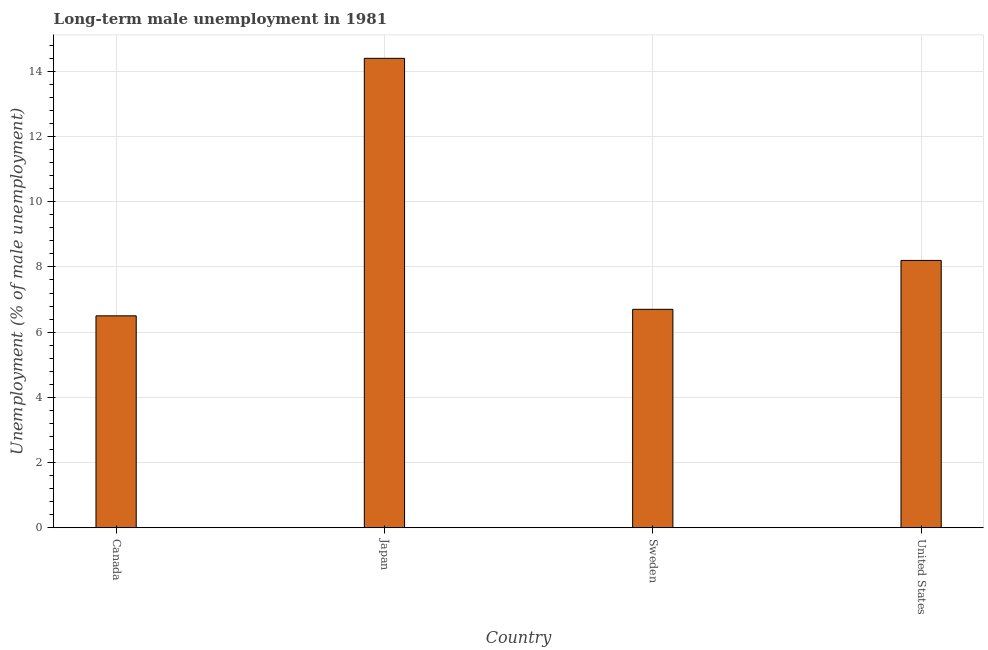Does the graph contain grids?
Give a very brief answer. Yes. What is the title of the graph?
Provide a succinct answer. Long-term male unemployment in 1981. What is the label or title of the Y-axis?
Provide a succinct answer. Unemployment (% of male unemployment). What is the long-term male unemployment in Japan?
Your response must be concise. 14.4. Across all countries, what is the maximum long-term male unemployment?
Provide a succinct answer. 14.4. In which country was the long-term male unemployment minimum?
Your response must be concise. Canada. What is the sum of the long-term male unemployment?
Offer a terse response. 35.8. What is the average long-term male unemployment per country?
Ensure brevity in your answer.  8.95. What is the median long-term male unemployment?
Your answer should be very brief. 7.45. In how many countries, is the long-term male unemployment greater than 7.6 %?
Your answer should be very brief. 2. What is the difference between the highest and the lowest long-term male unemployment?
Your response must be concise. 7.9. In how many countries, is the long-term male unemployment greater than the average long-term male unemployment taken over all countries?
Provide a short and direct response. 1. How many bars are there?
Your answer should be very brief. 4. Are the values on the major ticks of Y-axis written in scientific E-notation?
Your answer should be compact. No. What is the Unemployment (% of male unemployment) in Canada?
Your response must be concise. 6.5. What is the Unemployment (% of male unemployment) of Japan?
Offer a very short reply. 14.4. What is the Unemployment (% of male unemployment) of Sweden?
Ensure brevity in your answer.  6.7. What is the Unemployment (% of male unemployment) in United States?
Offer a very short reply. 8.2. What is the difference between the Unemployment (% of male unemployment) in Canada and United States?
Offer a terse response. -1.7. What is the ratio of the Unemployment (% of male unemployment) in Canada to that in Japan?
Provide a short and direct response. 0.45. What is the ratio of the Unemployment (% of male unemployment) in Canada to that in Sweden?
Offer a terse response. 0.97. What is the ratio of the Unemployment (% of male unemployment) in Canada to that in United States?
Your answer should be compact. 0.79. What is the ratio of the Unemployment (% of male unemployment) in Japan to that in Sweden?
Offer a terse response. 2.15. What is the ratio of the Unemployment (% of male unemployment) in Japan to that in United States?
Your answer should be compact. 1.76. What is the ratio of the Unemployment (% of male unemployment) in Sweden to that in United States?
Provide a succinct answer. 0.82. 